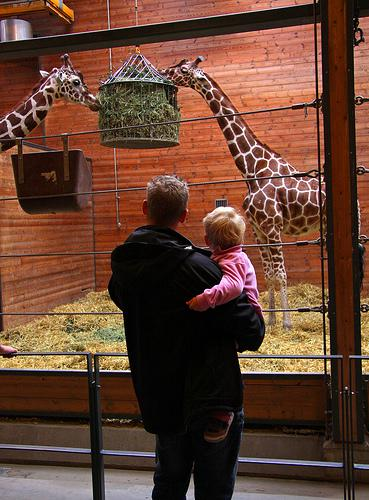Question: who is the man holding?
Choices:
A. The child.
B. A bride.
C. A baby.
D. A dog.
Answer with the letter. Answer: A Question: what color is the man's jacket?
Choices:
A. White.
B. Black.
C. Blue.
D. Silver.
Answer with the letter. Answer: B Question: what are the people looking at?
Choices:
A. Birds.
B. Dogs.
C. Cats.
D. Giraffes.
Answer with the letter. Answer: D Question: where are the giraffes?
Choices:
A. In the wild.
B. In a zoo.
C. In Africa.
D. Outside.
Answer with the letter. Answer: B Question: what color are the giraffe's spots?
Choices:
A. Brown.
B. Tan.
C. Orange.
D. Yellow.
Answer with the letter. Answer: A Question: why are the giraffes in the zoo?
Choices:
A. To look at.
B. To play.
C. To be safe.
D. To be viewed.
Answer with the letter. Answer: D 